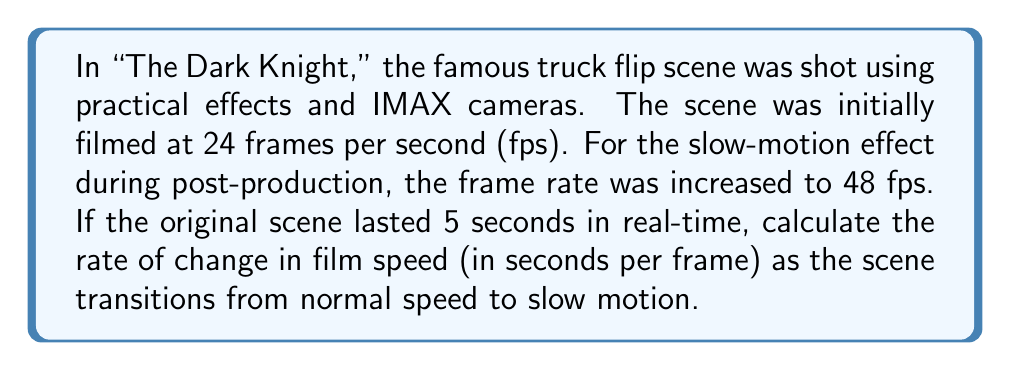Help me with this question. To solve this problem, we need to follow these steps:

1) First, let's calculate the duration of each frame at normal speed (24 fps):
   $$t_{normal} = \frac{1}{24} \approx 0.0417 \text{ seconds per frame}$$

2) Now, let's calculate the duration of each frame at slow motion speed (48 fps):
   $$t_{slow} = \frac{1}{48} = 0.0208 \text{ seconds per frame}$$

3) The rate of change is the difference in time per frame divided by the difference in frame rates:
   $$\text{Rate of Change} = \frac{\Delta t}{\Delta \text{fps}}$$

4) Calculate $\Delta t$:
   $$\Delta t = t_{normal} - t_{slow} = 0.0417 - 0.0208 = 0.0209 \text{ seconds}$$

5) Calculate $\Delta \text{fps}$:
   $$\Delta \text{fps} = 48 - 24 = 24 \text{ fps}$$

6) Now we can calculate the rate of change:
   $$\text{Rate of Change} = \frac{0.0209 \text{ seconds}}{24 \text{ fps}} \approx 0.000871 \text{ seconds per frame per fps}$$

This means that for each increase in frame rate, the duration of each frame decreases by approximately 0.000871 seconds.
Answer: The rate of change in film speed as the scene transitions from normal speed to slow motion is approximately $0.000871 \text{ seconds per frame per fps}$. 